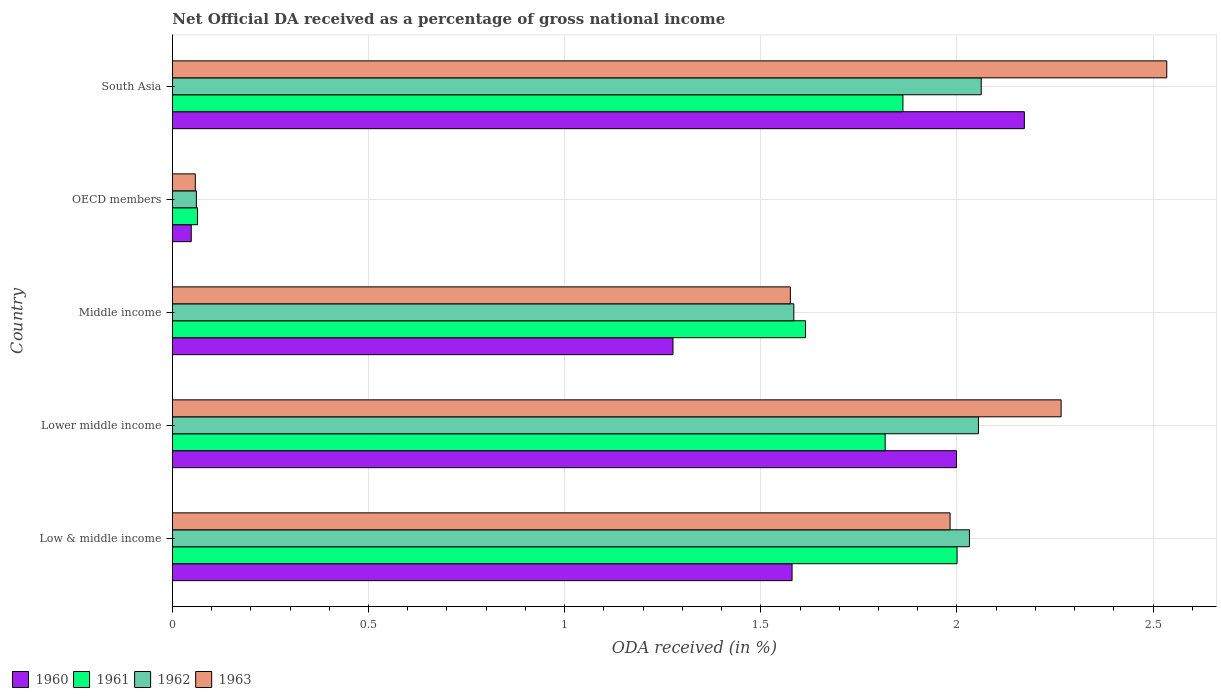Are the number of bars per tick equal to the number of legend labels?
Keep it short and to the point. Yes. How many bars are there on the 2nd tick from the top?
Make the answer very short. 4. What is the label of the 4th group of bars from the top?
Keep it short and to the point. Lower middle income. In how many cases, is the number of bars for a given country not equal to the number of legend labels?
Your answer should be compact. 0. What is the net official DA received in 1961 in Lower middle income?
Provide a short and direct response. 1.82. Across all countries, what is the maximum net official DA received in 1963?
Offer a very short reply. 2.53. Across all countries, what is the minimum net official DA received in 1962?
Ensure brevity in your answer.  0.06. In which country was the net official DA received in 1961 maximum?
Your answer should be very brief. Low & middle income. What is the total net official DA received in 1960 in the graph?
Make the answer very short. 7.07. What is the difference between the net official DA received in 1961 in Low & middle income and that in OECD members?
Provide a succinct answer. 1.94. What is the difference between the net official DA received in 1962 in South Asia and the net official DA received in 1960 in Low & middle income?
Make the answer very short. 0.48. What is the average net official DA received in 1962 per country?
Your response must be concise. 1.56. What is the difference between the net official DA received in 1962 and net official DA received in 1960 in Low & middle income?
Provide a short and direct response. 0.45. In how many countries, is the net official DA received in 1962 greater than 2.1 %?
Your answer should be compact. 0. What is the ratio of the net official DA received in 1961 in Middle income to that in OECD members?
Your answer should be compact. 25.19. Is the net official DA received in 1961 in Lower middle income less than that in Middle income?
Your answer should be very brief. No. What is the difference between the highest and the second highest net official DA received in 1963?
Provide a short and direct response. 0.27. What is the difference between the highest and the lowest net official DA received in 1961?
Your response must be concise. 1.94. In how many countries, is the net official DA received in 1963 greater than the average net official DA received in 1963 taken over all countries?
Offer a terse response. 3. Is it the case that in every country, the sum of the net official DA received in 1961 and net official DA received in 1963 is greater than the sum of net official DA received in 1962 and net official DA received in 1960?
Your answer should be very brief. No. What does the 4th bar from the top in Middle income represents?
Keep it short and to the point. 1960. Is it the case that in every country, the sum of the net official DA received in 1961 and net official DA received in 1960 is greater than the net official DA received in 1963?
Your answer should be compact. Yes. Are all the bars in the graph horizontal?
Offer a very short reply. Yes. How many countries are there in the graph?
Offer a very short reply. 5. What is the difference between two consecutive major ticks on the X-axis?
Ensure brevity in your answer.  0.5. Does the graph contain any zero values?
Provide a succinct answer. No. Does the graph contain grids?
Make the answer very short. Yes. Where does the legend appear in the graph?
Give a very brief answer. Bottom left. How many legend labels are there?
Your answer should be compact. 4. How are the legend labels stacked?
Ensure brevity in your answer.  Horizontal. What is the title of the graph?
Your answer should be compact. Net Official DA received as a percentage of gross national income. What is the label or title of the X-axis?
Ensure brevity in your answer.  ODA received (in %). What is the label or title of the Y-axis?
Give a very brief answer. Country. What is the ODA received (in %) in 1960 in Low & middle income?
Offer a very short reply. 1.58. What is the ODA received (in %) in 1961 in Low & middle income?
Make the answer very short. 2. What is the ODA received (in %) in 1962 in Low & middle income?
Offer a very short reply. 2.03. What is the ODA received (in %) in 1963 in Low & middle income?
Offer a terse response. 1.98. What is the ODA received (in %) in 1960 in Lower middle income?
Keep it short and to the point. 2. What is the ODA received (in %) in 1961 in Lower middle income?
Keep it short and to the point. 1.82. What is the ODA received (in %) of 1962 in Lower middle income?
Give a very brief answer. 2.05. What is the ODA received (in %) in 1963 in Lower middle income?
Your answer should be very brief. 2.27. What is the ODA received (in %) in 1960 in Middle income?
Offer a very short reply. 1.28. What is the ODA received (in %) of 1961 in Middle income?
Provide a short and direct response. 1.61. What is the ODA received (in %) of 1962 in Middle income?
Your answer should be compact. 1.58. What is the ODA received (in %) of 1963 in Middle income?
Provide a succinct answer. 1.58. What is the ODA received (in %) in 1960 in OECD members?
Provide a succinct answer. 0.05. What is the ODA received (in %) in 1961 in OECD members?
Provide a succinct answer. 0.06. What is the ODA received (in %) of 1962 in OECD members?
Give a very brief answer. 0.06. What is the ODA received (in %) of 1963 in OECD members?
Offer a very short reply. 0.06. What is the ODA received (in %) in 1960 in South Asia?
Your response must be concise. 2.17. What is the ODA received (in %) of 1961 in South Asia?
Your response must be concise. 1.86. What is the ODA received (in %) in 1962 in South Asia?
Your answer should be very brief. 2.06. What is the ODA received (in %) of 1963 in South Asia?
Provide a succinct answer. 2.53. Across all countries, what is the maximum ODA received (in %) in 1960?
Give a very brief answer. 2.17. Across all countries, what is the maximum ODA received (in %) of 1961?
Provide a short and direct response. 2. Across all countries, what is the maximum ODA received (in %) of 1962?
Provide a succinct answer. 2.06. Across all countries, what is the maximum ODA received (in %) in 1963?
Offer a terse response. 2.53. Across all countries, what is the minimum ODA received (in %) in 1960?
Give a very brief answer. 0.05. Across all countries, what is the minimum ODA received (in %) of 1961?
Provide a short and direct response. 0.06. Across all countries, what is the minimum ODA received (in %) in 1962?
Make the answer very short. 0.06. Across all countries, what is the minimum ODA received (in %) of 1963?
Offer a terse response. 0.06. What is the total ODA received (in %) of 1960 in the graph?
Provide a succinct answer. 7.07. What is the total ODA received (in %) of 1961 in the graph?
Offer a terse response. 7.36. What is the total ODA received (in %) in 1962 in the graph?
Ensure brevity in your answer.  7.79. What is the total ODA received (in %) in 1963 in the graph?
Give a very brief answer. 8.42. What is the difference between the ODA received (in %) in 1960 in Low & middle income and that in Lower middle income?
Ensure brevity in your answer.  -0.42. What is the difference between the ODA received (in %) of 1961 in Low & middle income and that in Lower middle income?
Offer a very short reply. 0.18. What is the difference between the ODA received (in %) of 1962 in Low & middle income and that in Lower middle income?
Keep it short and to the point. -0.02. What is the difference between the ODA received (in %) in 1963 in Low & middle income and that in Lower middle income?
Keep it short and to the point. -0.28. What is the difference between the ODA received (in %) in 1960 in Low & middle income and that in Middle income?
Your response must be concise. 0.3. What is the difference between the ODA received (in %) in 1961 in Low & middle income and that in Middle income?
Keep it short and to the point. 0.39. What is the difference between the ODA received (in %) of 1962 in Low & middle income and that in Middle income?
Your response must be concise. 0.45. What is the difference between the ODA received (in %) of 1963 in Low & middle income and that in Middle income?
Your answer should be very brief. 0.41. What is the difference between the ODA received (in %) of 1960 in Low & middle income and that in OECD members?
Make the answer very short. 1.53. What is the difference between the ODA received (in %) of 1961 in Low & middle income and that in OECD members?
Offer a terse response. 1.94. What is the difference between the ODA received (in %) in 1962 in Low & middle income and that in OECD members?
Ensure brevity in your answer.  1.97. What is the difference between the ODA received (in %) in 1963 in Low & middle income and that in OECD members?
Give a very brief answer. 1.92. What is the difference between the ODA received (in %) of 1960 in Low & middle income and that in South Asia?
Make the answer very short. -0.59. What is the difference between the ODA received (in %) in 1961 in Low & middle income and that in South Asia?
Your answer should be very brief. 0.14. What is the difference between the ODA received (in %) of 1962 in Low & middle income and that in South Asia?
Make the answer very short. -0.03. What is the difference between the ODA received (in %) of 1963 in Low & middle income and that in South Asia?
Your answer should be compact. -0.55. What is the difference between the ODA received (in %) in 1960 in Lower middle income and that in Middle income?
Keep it short and to the point. 0.72. What is the difference between the ODA received (in %) of 1961 in Lower middle income and that in Middle income?
Your response must be concise. 0.2. What is the difference between the ODA received (in %) of 1962 in Lower middle income and that in Middle income?
Give a very brief answer. 0.47. What is the difference between the ODA received (in %) in 1963 in Lower middle income and that in Middle income?
Give a very brief answer. 0.69. What is the difference between the ODA received (in %) in 1960 in Lower middle income and that in OECD members?
Give a very brief answer. 1.95. What is the difference between the ODA received (in %) in 1961 in Lower middle income and that in OECD members?
Provide a short and direct response. 1.75. What is the difference between the ODA received (in %) of 1962 in Lower middle income and that in OECD members?
Your response must be concise. 1.99. What is the difference between the ODA received (in %) of 1963 in Lower middle income and that in OECD members?
Ensure brevity in your answer.  2.21. What is the difference between the ODA received (in %) in 1960 in Lower middle income and that in South Asia?
Your response must be concise. -0.17. What is the difference between the ODA received (in %) of 1961 in Lower middle income and that in South Asia?
Provide a short and direct response. -0.05. What is the difference between the ODA received (in %) of 1962 in Lower middle income and that in South Asia?
Make the answer very short. -0.01. What is the difference between the ODA received (in %) of 1963 in Lower middle income and that in South Asia?
Give a very brief answer. -0.27. What is the difference between the ODA received (in %) in 1960 in Middle income and that in OECD members?
Offer a very short reply. 1.23. What is the difference between the ODA received (in %) of 1961 in Middle income and that in OECD members?
Offer a very short reply. 1.55. What is the difference between the ODA received (in %) in 1962 in Middle income and that in OECD members?
Offer a terse response. 1.52. What is the difference between the ODA received (in %) in 1963 in Middle income and that in OECD members?
Ensure brevity in your answer.  1.52. What is the difference between the ODA received (in %) in 1960 in Middle income and that in South Asia?
Provide a succinct answer. -0.9. What is the difference between the ODA received (in %) in 1961 in Middle income and that in South Asia?
Provide a succinct answer. -0.25. What is the difference between the ODA received (in %) of 1962 in Middle income and that in South Asia?
Offer a terse response. -0.48. What is the difference between the ODA received (in %) in 1963 in Middle income and that in South Asia?
Your response must be concise. -0.96. What is the difference between the ODA received (in %) of 1960 in OECD members and that in South Asia?
Your response must be concise. -2.12. What is the difference between the ODA received (in %) in 1961 in OECD members and that in South Asia?
Ensure brevity in your answer.  -1.8. What is the difference between the ODA received (in %) of 1962 in OECD members and that in South Asia?
Ensure brevity in your answer.  -2. What is the difference between the ODA received (in %) of 1963 in OECD members and that in South Asia?
Ensure brevity in your answer.  -2.48. What is the difference between the ODA received (in %) in 1960 in Low & middle income and the ODA received (in %) in 1961 in Lower middle income?
Make the answer very short. -0.24. What is the difference between the ODA received (in %) in 1960 in Low & middle income and the ODA received (in %) in 1962 in Lower middle income?
Provide a short and direct response. -0.48. What is the difference between the ODA received (in %) of 1960 in Low & middle income and the ODA received (in %) of 1963 in Lower middle income?
Your answer should be very brief. -0.69. What is the difference between the ODA received (in %) of 1961 in Low & middle income and the ODA received (in %) of 1962 in Lower middle income?
Keep it short and to the point. -0.05. What is the difference between the ODA received (in %) in 1961 in Low & middle income and the ODA received (in %) in 1963 in Lower middle income?
Your answer should be very brief. -0.27. What is the difference between the ODA received (in %) of 1962 in Low & middle income and the ODA received (in %) of 1963 in Lower middle income?
Provide a succinct answer. -0.23. What is the difference between the ODA received (in %) of 1960 in Low & middle income and the ODA received (in %) of 1961 in Middle income?
Make the answer very short. -0.03. What is the difference between the ODA received (in %) of 1960 in Low & middle income and the ODA received (in %) of 1962 in Middle income?
Your response must be concise. -0. What is the difference between the ODA received (in %) in 1960 in Low & middle income and the ODA received (in %) in 1963 in Middle income?
Your response must be concise. 0. What is the difference between the ODA received (in %) in 1961 in Low & middle income and the ODA received (in %) in 1962 in Middle income?
Provide a short and direct response. 0.42. What is the difference between the ODA received (in %) of 1961 in Low & middle income and the ODA received (in %) of 1963 in Middle income?
Offer a very short reply. 0.42. What is the difference between the ODA received (in %) of 1962 in Low & middle income and the ODA received (in %) of 1963 in Middle income?
Provide a short and direct response. 0.46. What is the difference between the ODA received (in %) of 1960 in Low & middle income and the ODA received (in %) of 1961 in OECD members?
Provide a succinct answer. 1.52. What is the difference between the ODA received (in %) of 1960 in Low & middle income and the ODA received (in %) of 1962 in OECD members?
Provide a short and direct response. 1.52. What is the difference between the ODA received (in %) in 1960 in Low & middle income and the ODA received (in %) in 1963 in OECD members?
Give a very brief answer. 1.52. What is the difference between the ODA received (in %) in 1961 in Low & middle income and the ODA received (in %) in 1962 in OECD members?
Provide a succinct answer. 1.94. What is the difference between the ODA received (in %) in 1961 in Low & middle income and the ODA received (in %) in 1963 in OECD members?
Provide a succinct answer. 1.94. What is the difference between the ODA received (in %) in 1962 in Low & middle income and the ODA received (in %) in 1963 in OECD members?
Keep it short and to the point. 1.97. What is the difference between the ODA received (in %) of 1960 in Low & middle income and the ODA received (in %) of 1961 in South Asia?
Keep it short and to the point. -0.28. What is the difference between the ODA received (in %) of 1960 in Low & middle income and the ODA received (in %) of 1962 in South Asia?
Keep it short and to the point. -0.48. What is the difference between the ODA received (in %) in 1960 in Low & middle income and the ODA received (in %) in 1963 in South Asia?
Offer a very short reply. -0.96. What is the difference between the ODA received (in %) of 1961 in Low & middle income and the ODA received (in %) of 1962 in South Asia?
Offer a very short reply. -0.06. What is the difference between the ODA received (in %) in 1961 in Low & middle income and the ODA received (in %) in 1963 in South Asia?
Your response must be concise. -0.53. What is the difference between the ODA received (in %) in 1962 in Low & middle income and the ODA received (in %) in 1963 in South Asia?
Keep it short and to the point. -0.5. What is the difference between the ODA received (in %) in 1960 in Lower middle income and the ODA received (in %) in 1961 in Middle income?
Your answer should be very brief. 0.38. What is the difference between the ODA received (in %) in 1960 in Lower middle income and the ODA received (in %) in 1962 in Middle income?
Keep it short and to the point. 0.41. What is the difference between the ODA received (in %) of 1960 in Lower middle income and the ODA received (in %) of 1963 in Middle income?
Your response must be concise. 0.42. What is the difference between the ODA received (in %) of 1961 in Lower middle income and the ODA received (in %) of 1962 in Middle income?
Your answer should be very brief. 0.23. What is the difference between the ODA received (in %) of 1961 in Lower middle income and the ODA received (in %) of 1963 in Middle income?
Provide a short and direct response. 0.24. What is the difference between the ODA received (in %) in 1962 in Lower middle income and the ODA received (in %) in 1963 in Middle income?
Provide a succinct answer. 0.48. What is the difference between the ODA received (in %) in 1960 in Lower middle income and the ODA received (in %) in 1961 in OECD members?
Make the answer very short. 1.93. What is the difference between the ODA received (in %) of 1960 in Lower middle income and the ODA received (in %) of 1962 in OECD members?
Keep it short and to the point. 1.94. What is the difference between the ODA received (in %) of 1960 in Lower middle income and the ODA received (in %) of 1963 in OECD members?
Your answer should be very brief. 1.94. What is the difference between the ODA received (in %) in 1961 in Lower middle income and the ODA received (in %) in 1962 in OECD members?
Give a very brief answer. 1.76. What is the difference between the ODA received (in %) in 1961 in Lower middle income and the ODA received (in %) in 1963 in OECD members?
Give a very brief answer. 1.76. What is the difference between the ODA received (in %) in 1962 in Lower middle income and the ODA received (in %) in 1963 in OECD members?
Your answer should be compact. 2. What is the difference between the ODA received (in %) in 1960 in Lower middle income and the ODA received (in %) in 1961 in South Asia?
Give a very brief answer. 0.14. What is the difference between the ODA received (in %) of 1960 in Lower middle income and the ODA received (in %) of 1962 in South Asia?
Provide a succinct answer. -0.06. What is the difference between the ODA received (in %) of 1960 in Lower middle income and the ODA received (in %) of 1963 in South Asia?
Provide a short and direct response. -0.54. What is the difference between the ODA received (in %) of 1961 in Lower middle income and the ODA received (in %) of 1962 in South Asia?
Keep it short and to the point. -0.24. What is the difference between the ODA received (in %) of 1961 in Lower middle income and the ODA received (in %) of 1963 in South Asia?
Your response must be concise. -0.72. What is the difference between the ODA received (in %) in 1962 in Lower middle income and the ODA received (in %) in 1963 in South Asia?
Provide a short and direct response. -0.48. What is the difference between the ODA received (in %) in 1960 in Middle income and the ODA received (in %) in 1961 in OECD members?
Make the answer very short. 1.21. What is the difference between the ODA received (in %) in 1960 in Middle income and the ODA received (in %) in 1962 in OECD members?
Provide a short and direct response. 1.21. What is the difference between the ODA received (in %) of 1960 in Middle income and the ODA received (in %) of 1963 in OECD members?
Provide a short and direct response. 1.22. What is the difference between the ODA received (in %) of 1961 in Middle income and the ODA received (in %) of 1962 in OECD members?
Give a very brief answer. 1.55. What is the difference between the ODA received (in %) in 1961 in Middle income and the ODA received (in %) in 1963 in OECD members?
Provide a succinct answer. 1.56. What is the difference between the ODA received (in %) of 1962 in Middle income and the ODA received (in %) of 1963 in OECD members?
Ensure brevity in your answer.  1.53. What is the difference between the ODA received (in %) in 1960 in Middle income and the ODA received (in %) in 1961 in South Asia?
Your answer should be compact. -0.59. What is the difference between the ODA received (in %) in 1960 in Middle income and the ODA received (in %) in 1962 in South Asia?
Offer a very short reply. -0.79. What is the difference between the ODA received (in %) in 1960 in Middle income and the ODA received (in %) in 1963 in South Asia?
Provide a succinct answer. -1.26. What is the difference between the ODA received (in %) in 1961 in Middle income and the ODA received (in %) in 1962 in South Asia?
Give a very brief answer. -0.45. What is the difference between the ODA received (in %) of 1961 in Middle income and the ODA received (in %) of 1963 in South Asia?
Your answer should be very brief. -0.92. What is the difference between the ODA received (in %) in 1962 in Middle income and the ODA received (in %) in 1963 in South Asia?
Provide a short and direct response. -0.95. What is the difference between the ODA received (in %) of 1960 in OECD members and the ODA received (in %) of 1961 in South Asia?
Provide a succinct answer. -1.81. What is the difference between the ODA received (in %) of 1960 in OECD members and the ODA received (in %) of 1962 in South Asia?
Give a very brief answer. -2.01. What is the difference between the ODA received (in %) in 1960 in OECD members and the ODA received (in %) in 1963 in South Asia?
Keep it short and to the point. -2.49. What is the difference between the ODA received (in %) of 1961 in OECD members and the ODA received (in %) of 1962 in South Asia?
Offer a very short reply. -2. What is the difference between the ODA received (in %) of 1961 in OECD members and the ODA received (in %) of 1963 in South Asia?
Your response must be concise. -2.47. What is the difference between the ODA received (in %) in 1962 in OECD members and the ODA received (in %) in 1963 in South Asia?
Provide a succinct answer. -2.47. What is the average ODA received (in %) of 1960 per country?
Your response must be concise. 1.42. What is the average ODA received (in %) in 1961 per country?
Your answer should be compact. 1.47. What is the average ODA received (in %) of 1962 per country?
Give a very brief answer. 1.56. What is the average ODA received (in %) in 1963 per country?
Provide a short and direct response. 1.68. What is the difference between the ODA received (in %) of 1960 and ODA received (in %) of 1961 in Low & middle income?
Provide a succinct answer. -0.42. What is the difference between the ODA received (in %) of 1960 and ODA received (in %) of 1962 in Low & middle income?
Offer a very short reply. -0.45. What is the difference between the ODA received (in %) in 1960 and ODA received (in %) in 1963 in Low & middle income?
Provide a short and direct response. -0.4. What is the difference between the ODA received (in %) in 1961 and ODA received (in %) in 1962 in Low & middle income?
Provide a succinct answer. -0.03. What is the difference between the ODA received (in %) in 1961 and ODA received (in %) in 1963 in Low & middle income?
Keep it short and to the point. 0.02. What is the difference between the ODA received (in %) in 1962 and ODA received (in %) in 1963 in Low & middle income?
Offer a terse response. 0.05. What is the difference between the ODA received (in %) in 1960 and ODA received (in %) in 1961 in Lower middle income?
Keep it short and to the point. 0.18. What is the difference between the ODA received (in %) in 1960 and ODA received (in %) in 1962 in Lower middle income?
Make the answer very short. -0.06. What is the difference between the ODA received (in %) in 1960 and ODA received (in %) in 1963 in Lower middle income?
Offer a terse response. -0.27. What is the difference between the ODA received (in %) of 1961 and ODA received (in %) of 1962 in Lower middle income?
Offer a very short reply. -0.24. What is the difference between the ODA received (in %) of 1961 and ODA received (in %) of 1963 in Lower middle income?
Your answer should be compact. -0.45. What is the difference between the ODA received (in %) in 1962 and ODA received (in %) in 1963 in Lower middle income?
Give a very brief answer. -0.21. What is the difference between the ODA received (in %) in 1960 and ODA received (in %) in 1961 in Middle income?
Give a very brief answer. -0.34. What is the difference between the ODA received (in %) in 1960 and ODA received (in %) in 1962 in Middle income?
Ensure brevity in your answer.  -0.31. What is the difference between the ODA received (in %) in 1960 and ODA received (in %) in 1963 in Middle income?
Provide a short and direct response. -0.3. What is the difference between the ODA received (in %) in 1961 and ODA received (in %) in 1962 in Middle income?
Make the answer very short. 0.03. What is the difference between the ODA received (in %) of 1961 and ODA received (in %) of 1963 in Middle income?
Provide a short and direct response. 0.04. What is the difference between the ODA received (in %) of 1962 and ODA received (in %) of 1963 in Middle income?
Keep it short and to the point. 0.01. What is the difference between the ODA received (in %) of 1960 and ODA received (in %) of 1961 in OECD members?
Ensure brevity in your answer.  -0.02. What is the difference between the ODA received (in %) of 1960 and ODA received (in %) of 1962 in OECD members?
Your answer should be compact. -0.01. What is the difference between the ODA received (in %) of 1960 and ODA received (in %) of 1963 in OECD members?
Provide a succinct answer. -0.01. What is the difference between the ODA received (in %) in 1961 and ODA received (in %) in 1962 in OECD members?
Your answer should be very brief. 0. What is the difference between the ODA received (in %) in 1961 and ODA received (in %) in 1963 in OECD members?
Provide a short and direct response. 0.01. What is the difference between the ODA received (in %) in 1962 and ODA received (in %) in 1963 in OECD members?
Your answer should be compact. 0. What is the difference between the ODA received (in %) of 1960 and ODA received (in %) of 1961 in South Asia?
Provide a short and direct response. 0.31. What is the difference between the ODA received (in %) in 1960 and ODA received (in %) in 1962 in South Asia?
Ensure brevity in your answer.  0.11. What is the difference between the ODA received (in %) of 1960 and ODA received (in %) of 1963 in South Asia?
Your answer should be compact. -0.36. What is the difference between the ODA received (in %) in 1961 and ODA received (in %) in 1962 in South Asia?
Offer a terse response. -0.2. What is the difference between the ODA received (in %) of 1961 and ODA received (in %) of 1963 in South Asia?
Provide a succinct answer. -0.67. What is the difference between the ODA received (in %) in 1962 and ODA received (in %) in 1963 in South Asia?
Your answer should be very brief. -0.47. What is the ratio of the ODA received (in %) in 1960 in Low & middle income to that in Lower middle income?
Make the answer very short. 0.79. What is the ratio of the ODA received (in %) of 1961 in Low & middle income to that in Lower middle income?
Provide a short and direct response. 1.1. What is the ratio of the ODA received (in %) in 1962 in Low & middle income to that in Lower middle income?
Keep it short and to the point. 0.99. What is the ratio of the ODA received (in %) of 1963 in Low & middle income to that in Lower middle income?
Your answer should be very brief. 0.88. What is the ratio of the ODA received (in %) of 1960 in Low & middle income to that in Middle income?
Make the answer very short. 1.24. What is the ratio of the ODA received (in %) in 1961 in Low & middle income to that in Middle income?
Ensure brevity in your answer.  1.24. What is the ratio of the ODA received (in %) of 1962 in Low & middle income to that in Middle income?
Ensure brevity in your answer.  1.28. What is the ratio of the ODA received (in %) of 1963 in Low & middle income to that in Middle income?
Make the answer very short. 1.26. What is the ratio of the ODA received (in %) of 1960 in Low & middle income to that in OECD members?
Provide a short and direct response. 32.83. What is the ratio of the ODA received (in %) in 1961 in Low & middle income to that in OECD members?
Provide a succinct answer. 31.22. What is the ratio of the ODA received (in %) in 1962 in Low & middle income to that in OECD members?
Ensure brevity in your answer.  33.2. What is the ratio of the ODA received (in %) in 1963 in Low & middle income to that in OECD members?
Make the answer very short. 33.89. What is the ratio of the ODA received (in %) of 1960 in Low & middle income to that in South Asia?
Your response must be concise. 0.73. What is the ratio of the ODA received (in %) of 1961 in Low & middle income to that in South Asia?
Make the answer very short. 1.07. What is the ratio of the ODA received (in %) of 1962 in Low & middle income to that in South Asia?
Give a very brief answer. 0.99. What is the ratio of the ODA received (in %) of 1963 in Low & middle income to that in South Asia?
Ensure brevity in your answer.  0.78. What is the ratio of the ODA received (in %) of 1960 in Lower middle income to that in Middle income?
Provide a short and direct response. 1.57. What is the ratio of the ODA received (in %) in 1961 in Lower middle income to that in Middle income?
Offer a terse response. 1.13. What is the ratio of the ODA received (in %) in 1962 in Lower middle income to that in Middle income?
Keep it short and to the point. 1.3. What is the ratio of the ODA received (in %) of 1963 in Lower middle income to that in Middle income?
Your answer should be compact. 1.44. What is the ratio of the ODA received (in %) in 1960 in Lower middle income to that in OECD members?
Offer a very short reply. 41.54. What is the ratio of the ODA received (in %) of 1961 in Lower middle income to that in OECD members?
Offer a terse response. 28.36. What is the ratio of the ODA received (in %) of 1962 in Lower middle income to that in OECD members?
Your answer should be very brief. 33.57. What is the ratio of the ODA received (in %) in 1963 in Lower middle income to that in OECD members?
Provide a succinct answer. 38.73. What is the ratio of the ODA received (in %) of 1960 in Lower middle income to that in South Asia?
Your response must be concise. 0.92. What is the ratio of the ODA received (in %) in 1961 in Lower middle income to that in South Asia?
Make the answer very short. 0.98. What is the ratio of the ODA received (in %) of 1962 in Lower middle income to that in South Asia?
Offer a terse response. 1. What is the ratio of the ODA received (in %) in 1963 in Lower middle income to that in South Asia?
Keep it short and to the point. 0.89. What is the ratio of the ODA received (in %) in 1960 in Middle income to that in OECD members?
Provide a short and direct response. 26.52. What is the ratio of the ODA received (in %) of 1961 in Middle income to that in OECD members?
Provide a succinct answer. 25.19. What is the ratio of the ODA received (in %) of 1962 in Middle income to that in OECD members?
Provide a succinct answer. 25.88. What is the ratio of the ODA received (in %) of 1963 in Middle income to that in OECD members?
Give a very brief answer. 26.93. What is the ratio of the ODA received (in %) in 1960 in Middle income to that in South Asia?
Offer a terse response. 0.59. What is the ratio of the ODA received (in %) in 1961 in Middle income to that in South Asia?
Make the answer very short. 0.87. What is the ratio of the ODA received (in %) of 1962 in Middle income to that in South Asia?
Provide a short and direct response. 0.77. What is the ratio of the ODA received (in %) in 1963 in Middle income to that in South Asia?
Your answer should be compact. 0.62. What is the ratio of the ODA received (in %) in 1960 in OECD members to that in South Asia?
Offer a very short reply. 0.02. What is the ratio of the ODA received (in %) of 1961 in OECD members to that in South Asia?
Your response must be concise. 0.03. What is the ratio of the ODA received (in %) in 1962 in OECD members to that in South Asia?
Keep it short and to the point. 0.03. What is the ratio of the ODA received (in %) in 1963 in OECD members to that in South Asia?
Offer a terse response. 0.02. What is the difference between the highest and the second highest ODA received (in %) of 1960?
Provide a succinct answer. 0.17. What is the difference between the highest and the second highest ODA received (in %) in 1961?
Provide a succinct answer. 0.14. What is the difference between the highest and the second highest ODA received (in %) of 1962?
Your answer should be compact. 0.01. What is the difference between the highest and the second highest ODA received (in %) in 1963?
Your answer should be compact. 0.27. What is the difference between the highest and the lowest ODA received (in %) of 1960?
Ensure brevity in your answer.  2.12. What is the difference between the highest and the lowest ODA received (in %) in 1961?
Ensure brevity in your answer.  1.94. What is the difference between the highest and the lowest ODA received (in %) in 1962?
Your response must be concise. 2. What is the difference between the highest and the lowest ODA received (in %) in 1963?
Ensure brevity in your answer.  2.48. 